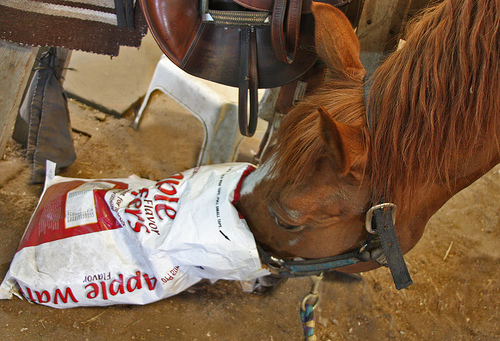<image>
Is the horse head in the feed bag? Yes. The horse head is contained within or inside the feed bag, showing a containment relationship. 